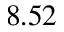Convert formula to latex. <formula><loc_0><loc_0><loc_500><loc_500>8 . 5 2</formula> 